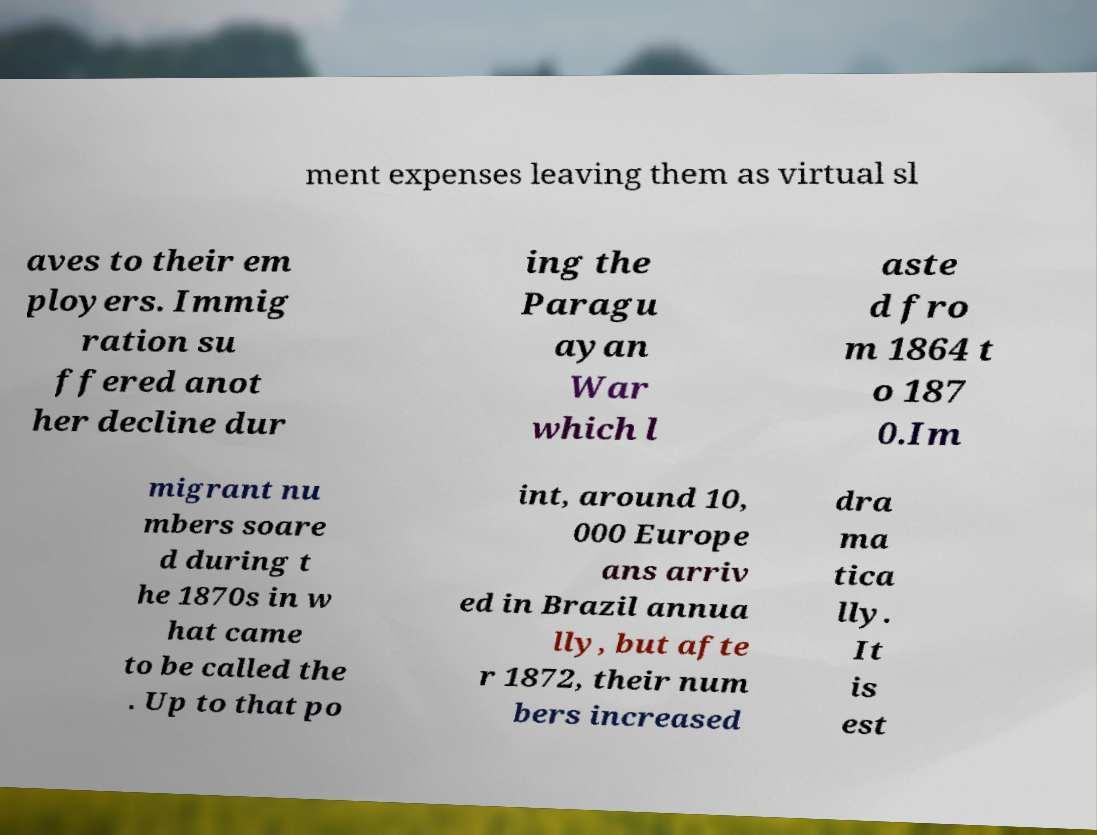For documentation purposes, I need the text within this image transcribed. Could you provide that? ment expenses leaving them as virtual sl aves to their em ployers. Immig ration su ffered anot her decline dur ing the Paragu ayan War which l aste d fro m 1864 t o 187 0.Im migrant nu mbers soare d during t he 1870s in w hat came to be called the . Up to that po int, around 10, 000 Europe ans arriv ed in Brazil annua lly, but afte r 1872, their num bers increased dra ma tica lly. It is est 